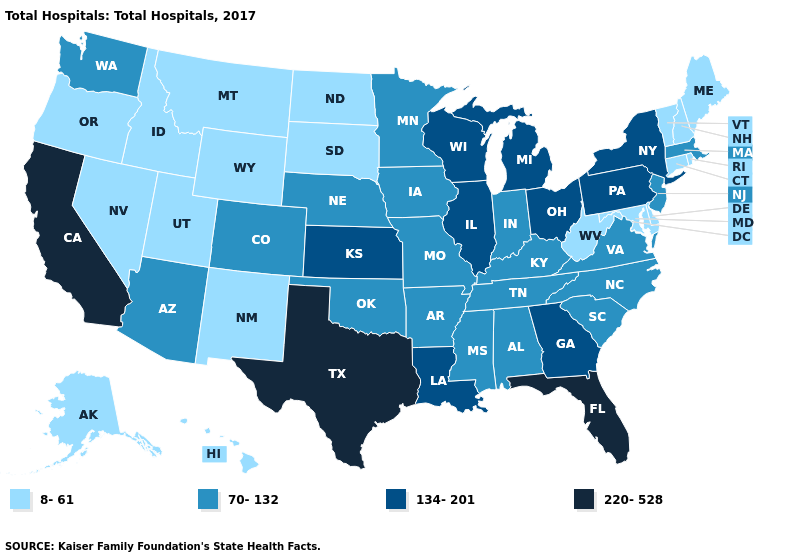Does Rhode Island have the lowest value in the Northeast?
Quick response, please. Yes. Name the states that have a value in the range 220-528?
Short answer required. California, Florida, Texas. Among the states that border Rhode Island , which have the lowest value?
Give a very brief answer. Connecticut. Does South Dakota have the highest value in the MidWest?
Short answer required. No. Does Vermont have a lower value than Pennsylvania?
Short answer required. Yes. Does New Mexico have the same value as North Carolina?
Quick response, please. No. What is the lowest value in the West?
Write a very short answer. 8-61. Does Louisiana have the lowest value in the South?
Write a very short answer. No. Name the states that have a value in the range 220-528?
Answer briefly. California, Florida, Texas. What is the value of Alabama?
Concise answer only. 70-132. Does the map have missing data?
Concise answer only. No. Name the states that have a value in the range 134-201?
Give a very brief answer. Georgia, Illinois, Kansas, Louisiana, Michigan, New York, Ohio, Pennsylvania, Wisconsin. What is the value of Minnesota?
Quick response, please. 70-132. Among the states that border Delaware , does Pennsylvania have the lowest value?
Quick response, please. No. What is the highest value in the South ?
Give a very brief answer. 220-528. 